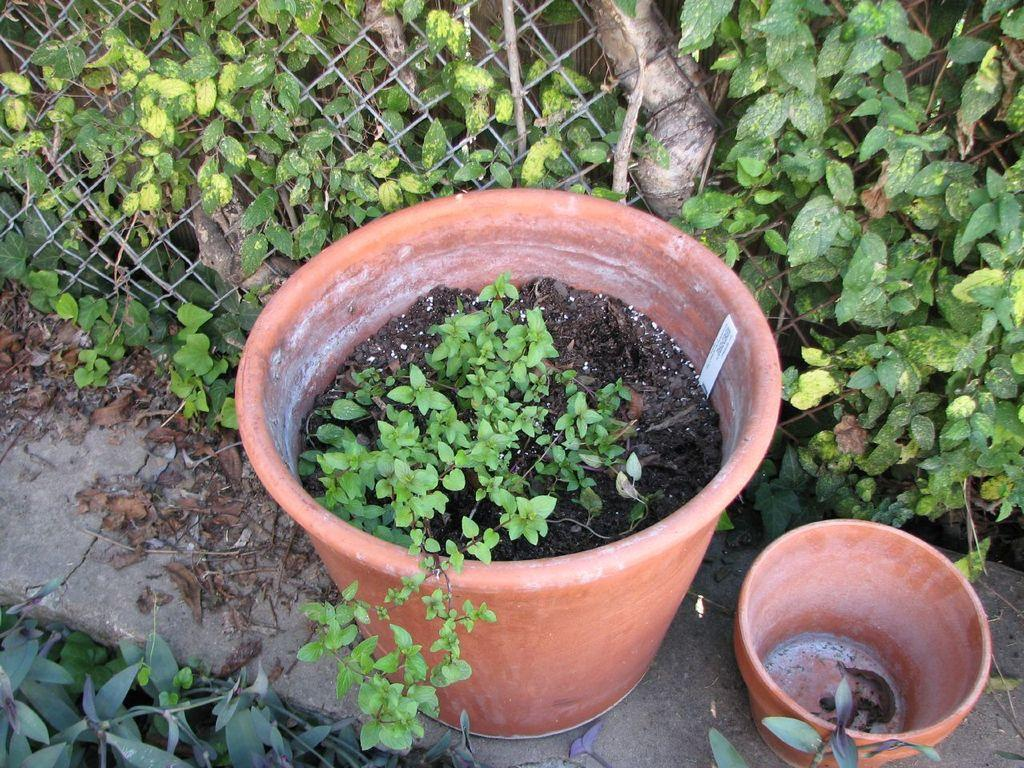What type of objects can be seen in the image? There are plant pots in the image. What is in front of the plants? There is fencing in front of the plants. What type of cabbage is being eaten by the goat in the image? There is no cabbage or goat present in the image. Can you see any windows in the image? The provided facts do not mention any windows in the image. 